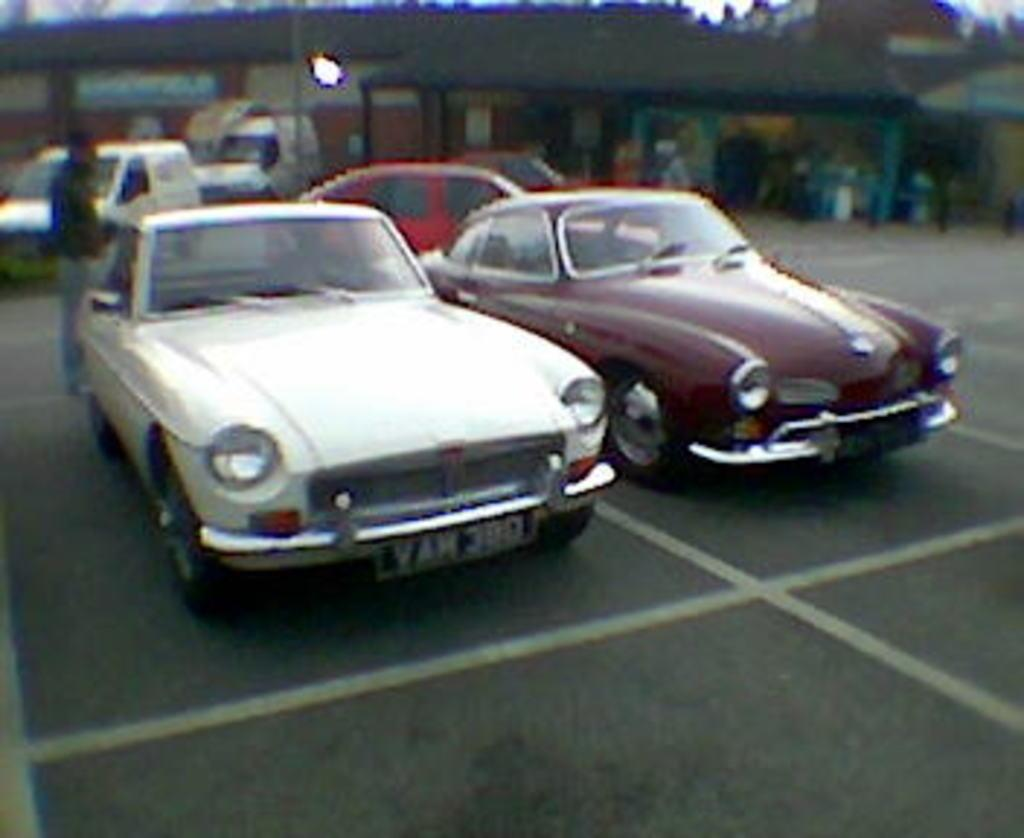What is the main subject of the image? There is a person standing in the image. What else can be seen in the image besides the person? Cars are visible on the road in the image. What is in the background of the image? There is a wall in the background of the image. What type of arch can be seen in the image? There is no arch present in the image. Is there a hospital visible in the image? There is no hospital visible in the image. 